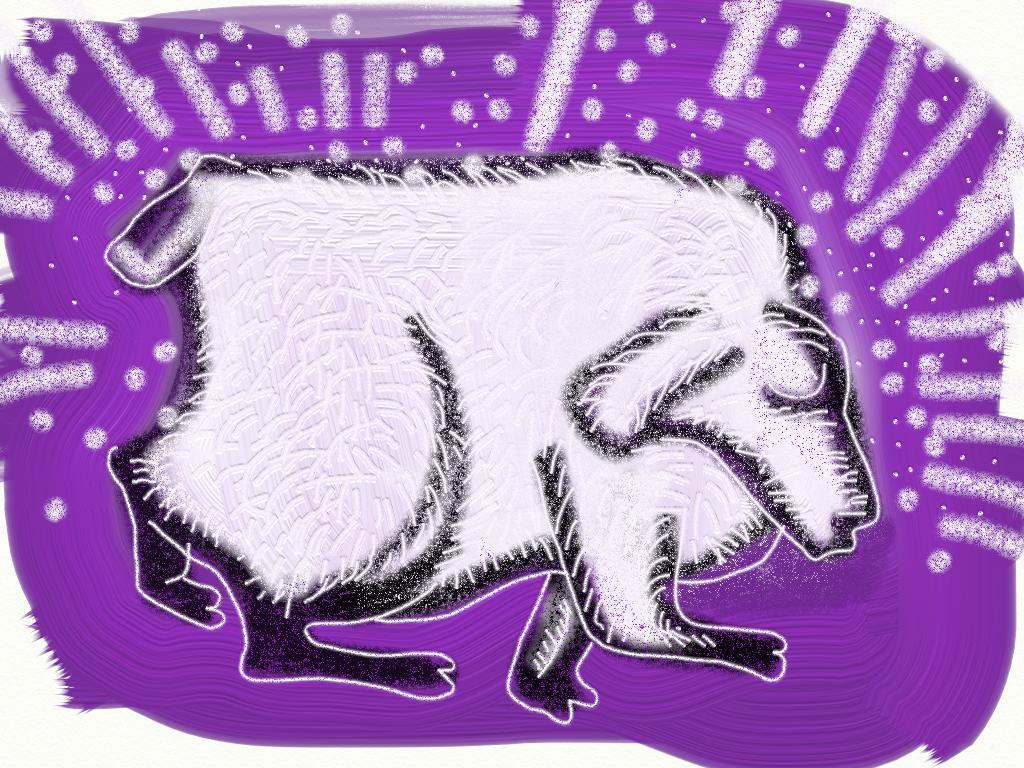In one or two sentences, can you explain what this image depicts? Here we can see picture of an animal and around it we can see violet color and there are designs on it. 